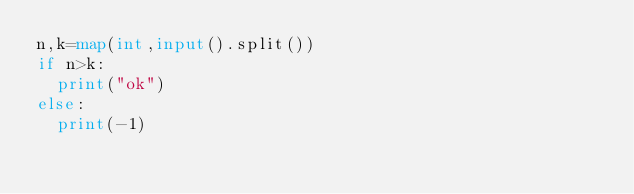Convert code to text. <code><loc_0><loc_0><loc_500><loc_500><_Python_>n,k=map(int,input().split())
if n>k:
  print("ok")
else:
  print(-1)</code> 